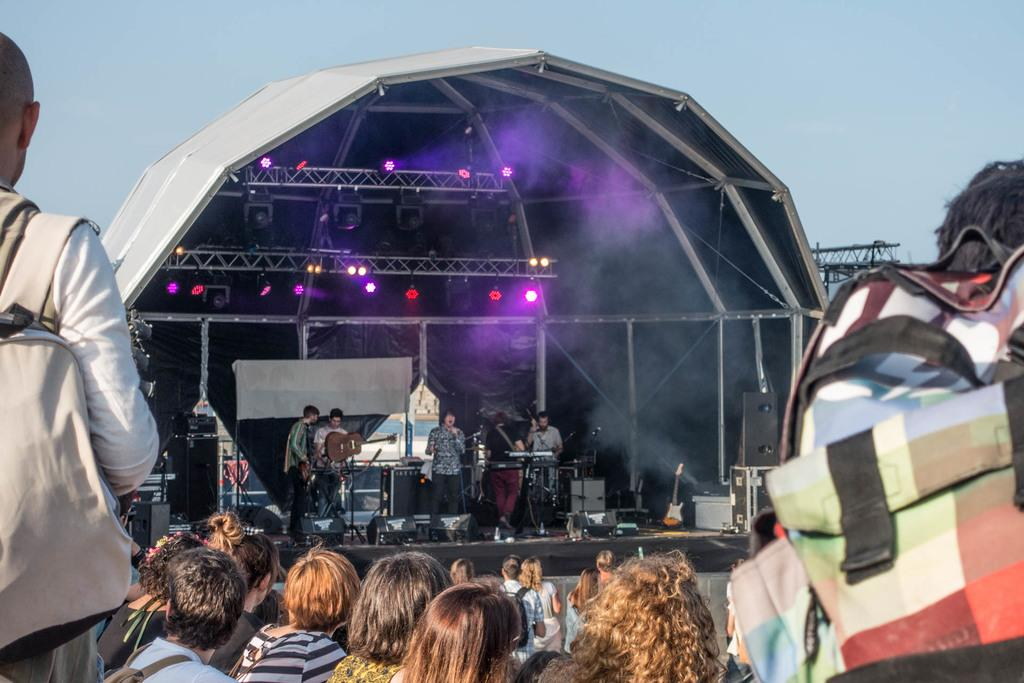Who or what is present in the image? There are people in the image. What are the people doing in the image? The people are holding instruments in their hands. What else can be seen in the image besides the people? There are lights visible in the image. What is visible in the background of the image? The sky is visible in the background of the image. What type of story is being told by the people in the image? There is no story being told by the people in the image; they are holding instruments, which suggests they might be playing music. 